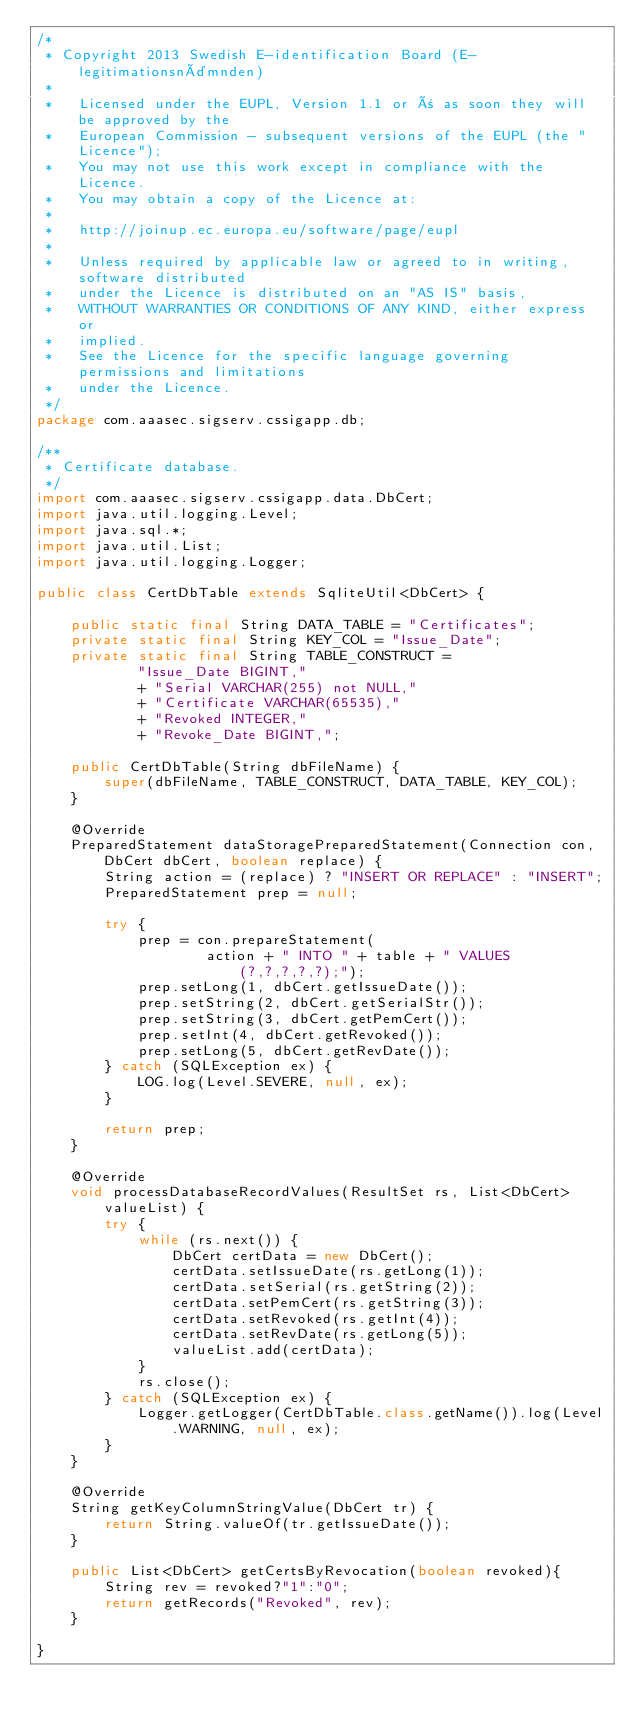Convert code to text. <code><loc_0><loc_0><loc_500><loc_500><_Java_>/*
 * Copyright 2013 Swedish E-identification Board (E-legitimationsnämnden)
 *  		 
 *   Licensed under the EUPL, Version 1.1 or ñ as soon they will be approved by the 
 *   European Commission - subsequent versions of the EUPL (the "Licence");
 *   You may not use this work except in compliance with the Licence. 
 *   You may obtain a copy of the Licence at:
 * 
 *   http://joinup.ec.europa.eu/software/page/eupl 
 * 
 *   Unless required by applicable law or agreed to in writing, software distributed 
 *   under the Licence is distributed on an "AS IS" basis,
 *   WITHOUT WARRANTIES OR CONDITIONS OF ANY KIND, either express or 
 *   implied.
 *   See the Licence for the specific language governing permissions and limitations 
 *   under the Licence.
 */
package com.aaasec.sigserv.cssigapp.db;

/**
 * Certificate database.
 */
import com.aaasec.sigserv.cssigapp.data.DbCert;
import java.util.logging.Level;
import java.sql.*;
import java.util.List;
import java.util.logging.Logger;

public class CertDbTable extends SqliteUtil<DbCert> {

    public static final String DATA_TABLE = "Certificates";
    private static final String KEY_COL = "Issue_Date";
    private static final String TABLE_CONSTRUCT =
            "Issue_Date BIGINT,"
            + "Serial VARCHAR(255) not NULL,"
            + "Certificate VARCHAR(65535),"
            + "Revoked INTEGER,"
            + "Revoke_Date BIGINT,";

    public CertDbTable(String dbFileName) {
        super(dbFileName, TABLE_CONSTRUCT, DATA_TABLE, KEY_COL);
    }

    @Override
    PreparedStatement dataStoragePreparedStatement(Connection con, DbCert dbCert, boolean replace) {
        String action = (replace) ? "INSERT OR REPLACE" : "INSERT";
        PreparedStatement prep = null;

        try {
            prep = con.prepareStatement(
                    action + " INTO " + table + " VALUES (?,?,?,?,?);");
            prep.setLong(1, dbCert.getIssueDate());
            prep.setString(2, dbCert.getSerialStr());
            prep.setString(3, dbCert.getPemCert());
            prep.setInt(4, dbCert.getRevoked());
            prep.setLong(5, dbCert.getRevDate());
        } catch (SQLException ex) {
            LOG.log(Level.SEVERE, null, ex);
        }

        return prep;
    }

    @Override
    void processDatabaseRecordValues(ResultSet rs, List<DbCert> valueList) {
        try {
            while (rs.next()) {
                DbCert certData = new DbCert();
                certData.setIssueDate(rs.getLong(1));
                certData.setSerial(rs.getString(2));
                certData.setPemCert(rs.getString(3));
                certData.setRevoked(rs.getInt(4));
                certData.setRevDate(rs.getLong(5));
                valueList.add(certData);
            }
            rs.close();
        } catch (SQLException ex) {
            Logger.getLogger(CertDbTable.class.getName()).log(Level.WARNING, null, ex);
        }
    }

    @Override
    String getKeyColumnStringValue(DbCert tr) {
        return String.valueOf(tr.getIssueDate());
    }
    
    public List<DbCert> getCertsByRevocation(boolean revoked){
        String rev = revoked?"1":"0";
        return getRecords("Revoked", rev);
    }
    
}
</code> 